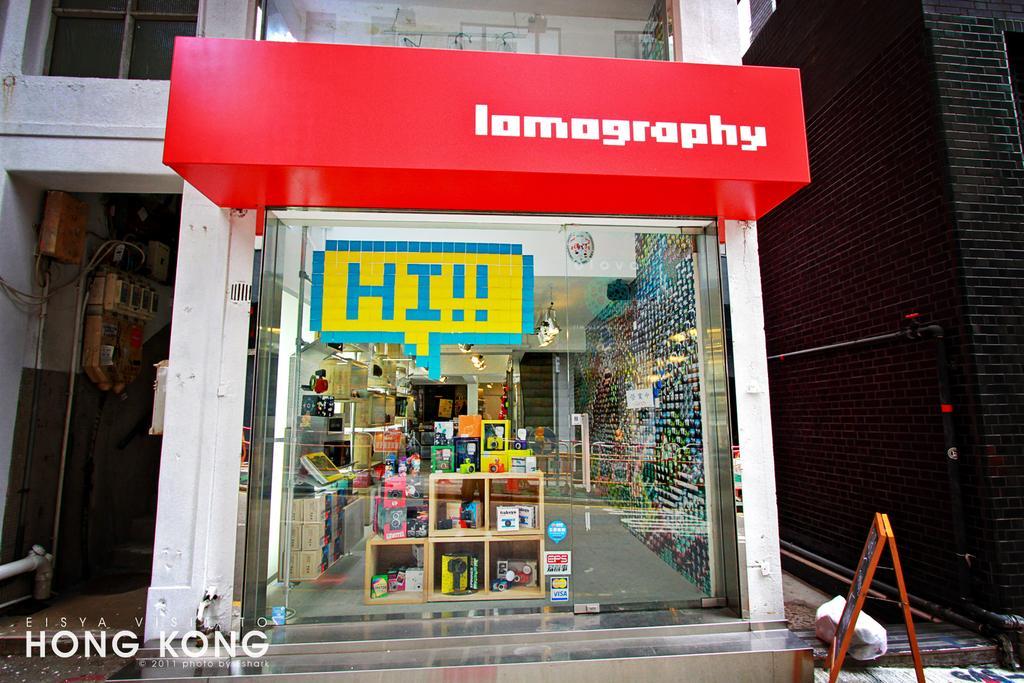Please provide a concise description of this image. This is the picture of a building. In this image there are objects in the cupboard inside the building and there are objects on the table behind the door. At the top there are lights inside the building. There is a poster on the mirror. On the right side of the image there is a board and there are pipes on the wall. On the left side of the image there are devices and pipes, wires on the wall. 